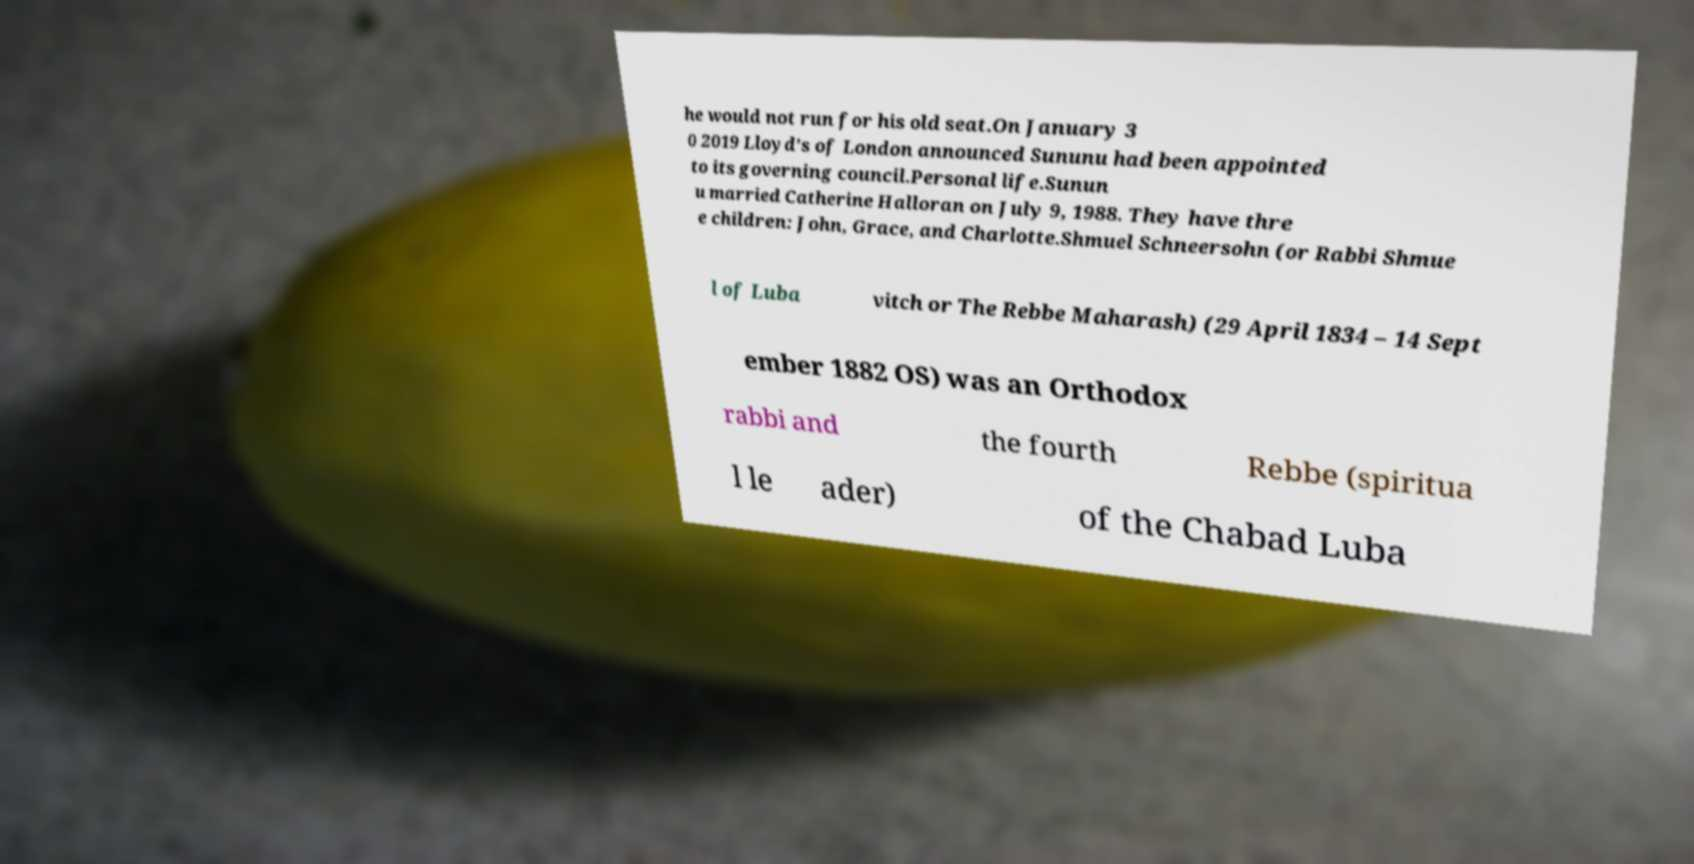I need the written content from this picture converted into text. Can you do that? he would not run for his old seat.On January 3 0 2019 Lloyd's of London announced Sununu had been appointed to its governing council.Personal life.Sunun u married Catherine Halloran on July 9, 1988. They have thre e children: John, Grace, and Charlotte.Shmuel Schneersohn (or Rabbi Shmue l of Luba vitch or The Rebbe Maharash) (29 April 1834 – 14 Sept ember 1882 OS) was an Orthodox rabbi and the fourth Rebbe (spiritua l le ader) of the Chabad Luba 